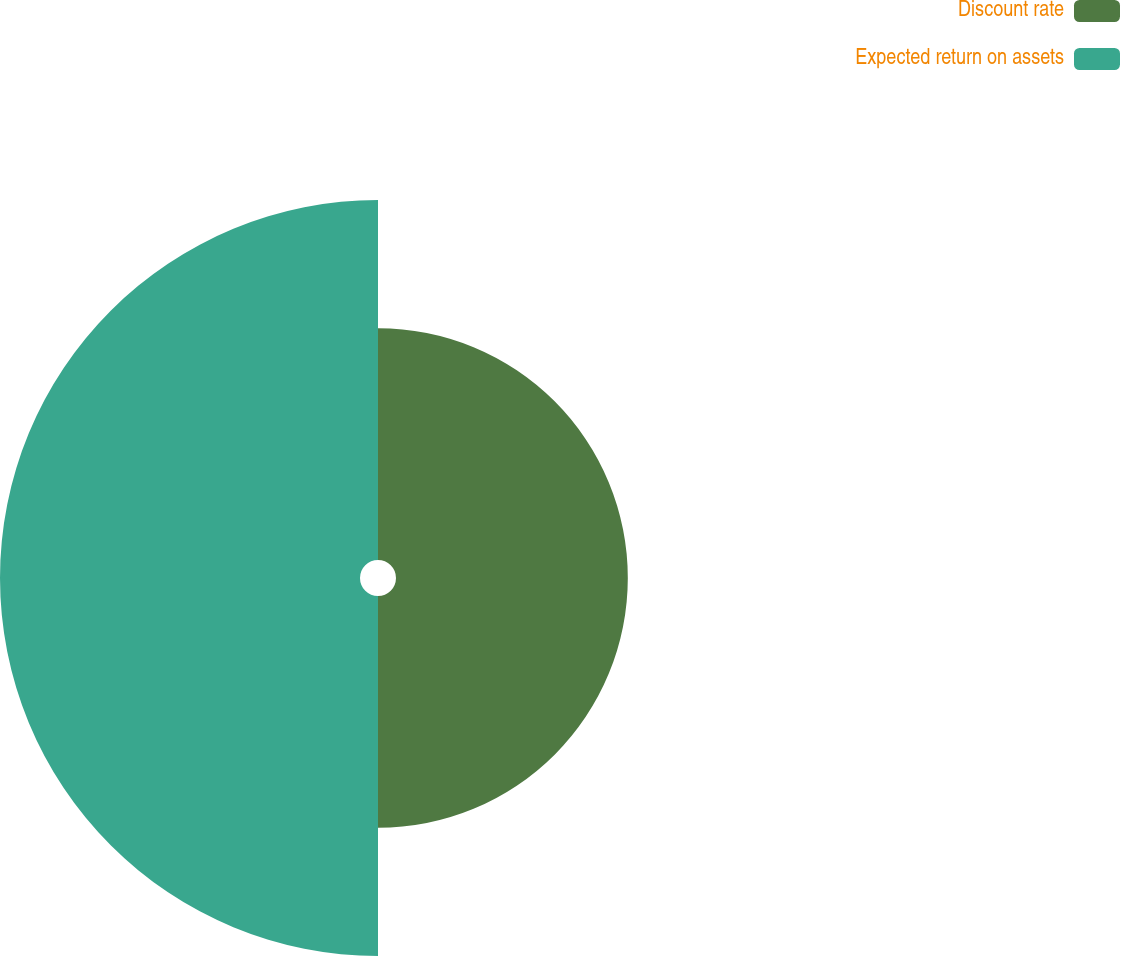<chart> <loc_0><loc_0><loc_500><loc_500><pie_chart><fcel>Discount rate<fcel>Expected return on assets<nl><fcel>39.17%<fcel>60.83%<nl></chart> 